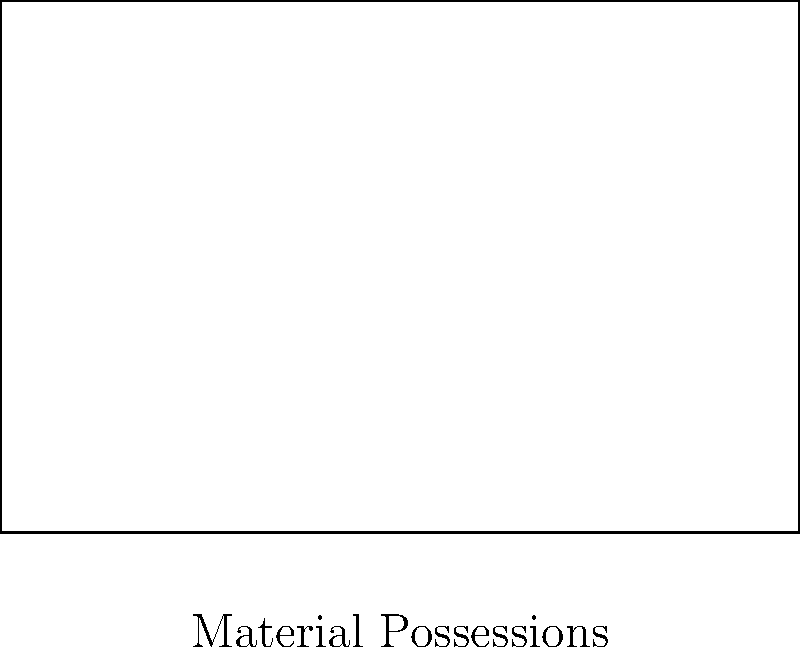In the context of balancing material possessions and personal fulfillment, a rectangle is drawn on a coordinate plane. The rectangle represents the relationship between these two aspects of life. If point A is at the origin (0,0), B is at (6,0), and D is at (0,4), what is the area of this rectangle? How might this area represent the overall life satisfaction of an individual struggling with consumerism? To solve this problem, we'll follow these steps:

1. Identify the dimensions of the rectangle:
   - The x-coordinate of point B gives the width: 6 units
   - The y-coordinate of point D gives the height: 4 units

2. Calculate the area of the rectangle using the formula:
   $$ \text{Area} = \text{width} \times \text{height} $$
   $$ \text{Area} = 6 \times 4 = 24 \text{ square units} $$

3. Interpretation in the context of consumerism and personal fulfillment:
   - The width (6 units) represents the extent of material possessions
   - The height (4 units) represents the level of personal fulfillment
   - The area (24 square units) can be interpreted as overall life satisfaction

4. Analysis for individuals struggling with consumerism:
   - A larger width (more material possessions) doesn't necessarily lead to a proportionally larger area (life satisfaction)
   - Increasing the height (personal fulfillment) can have a significant impact on the total area
   - A balanced approach, considering both dimensions, leads to optimal overall satisfaction

5. Therapeutic implications:
   - Help clients recognize that excessive focus on material possessions (increasing width) may not proportionally increase life satisfaction
   - Encourage clients to invest in personal fulfillment (increasing height) as a means to enhance overall life satisfaction
   - Guide clients towards finding an optimal balance between material possessions and personal fulfillment
Answer: 24 square units; represents overall life satisfaction balancing material possessions and personal fulfillment 